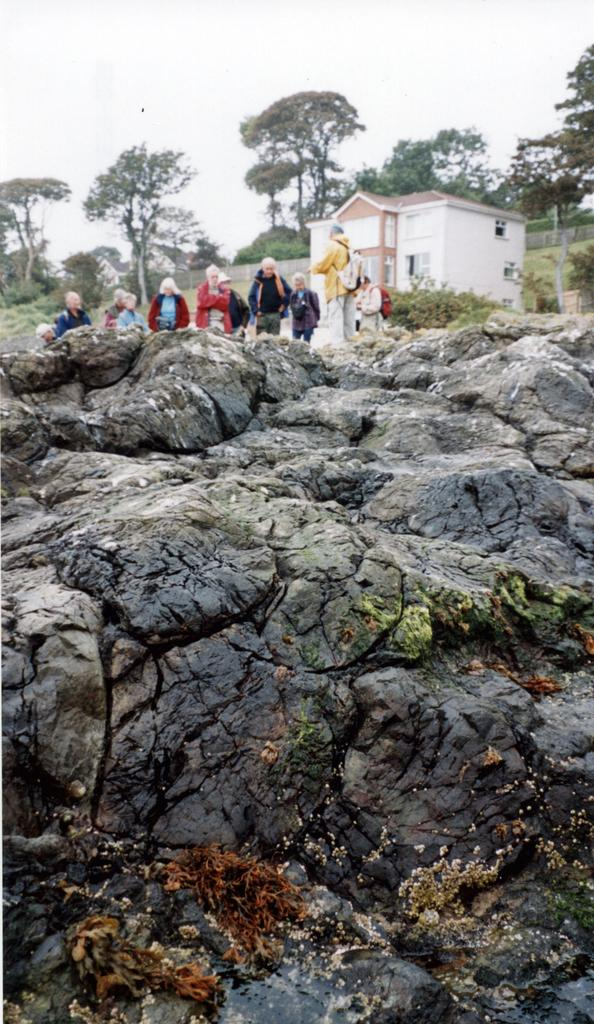What is the main object in the foreground of the image? There is a rock in the image. What can be seen in the background of the image? In the background, there is a building, people, plants, a fence, the sky, and trees. Can you describe the building in the background? The building has windows. What type of vegetation is present in the background? Plants and trees are present in the background. What type of floor can be seen in the image? There is no floor visible in the image, as it primarily features a rock in the foreground and various elements in the background. What is the taste of the rock in the image? Rocks do not have a taste, as they are inanimate objects. 